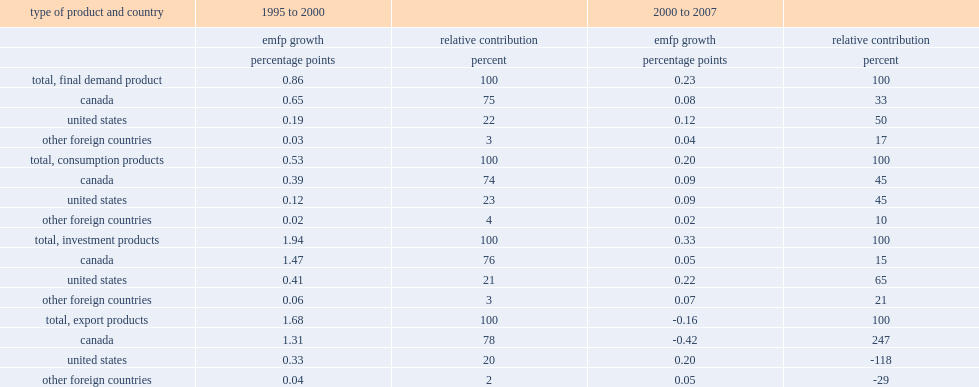Between 1995 and 2000, what percent of mfp growth in canada came from productivity growth in foreign countries? 25. How many percent of the overall foreign contribution to canada's mfp has increased during the period from 2000 to 2007? 67. 